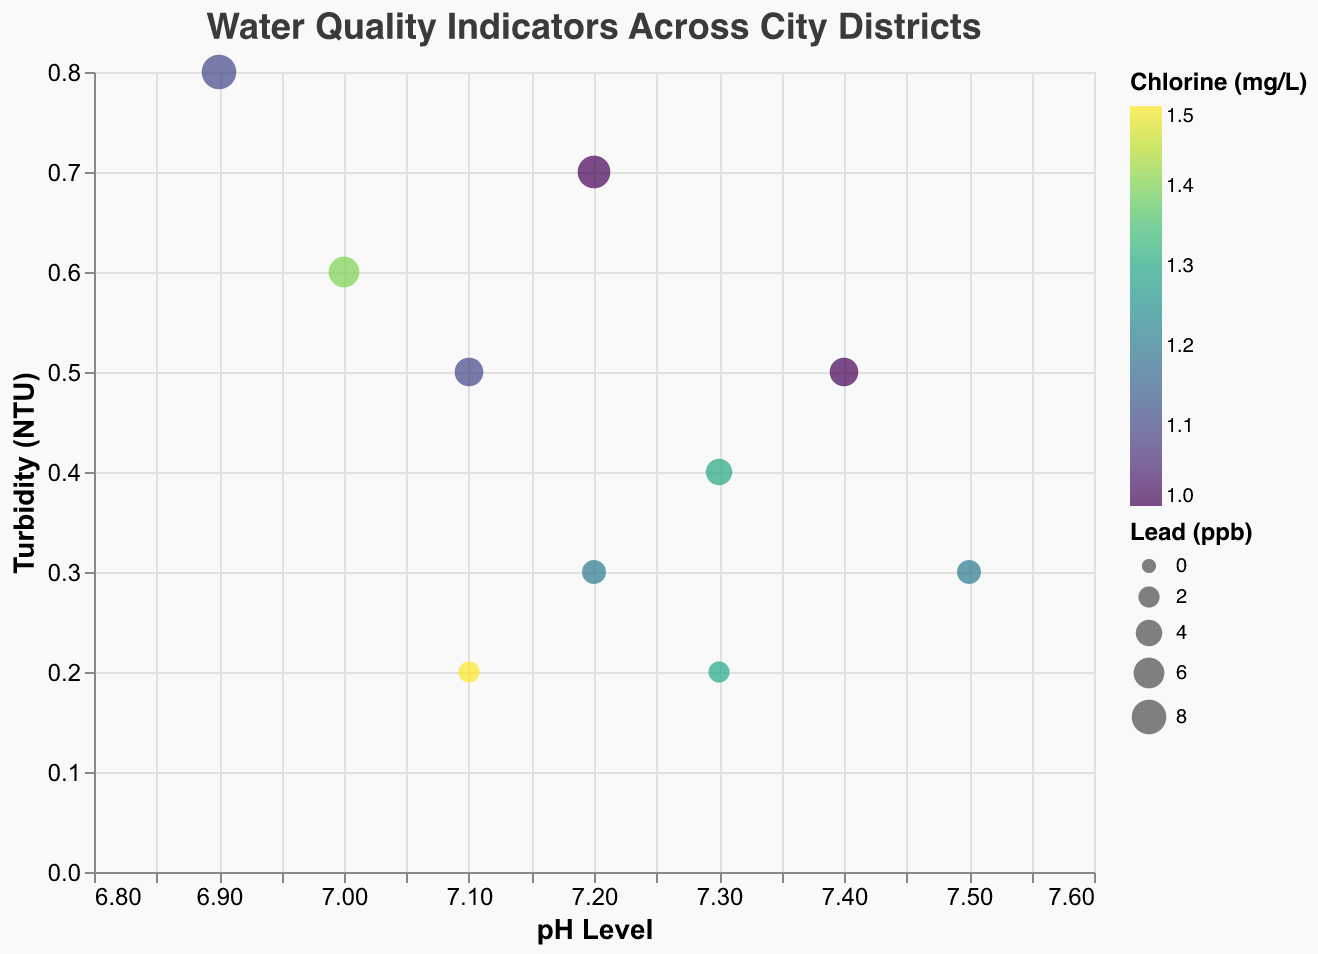How many districts are displayed in the figure? To answer this question, you simply need to count the number of distinct points representing districts on the plot. There are 10 distinct points, each corresponding to one district.
Answer: 10 Which district has the lowest pH value? To determine the district with the lowest pH value, look for the data point that is furthest to the left on the x-axis. The "Industrial Park" district has the lowest pH value of 6.9.
Answer: Industrial Park What is the range of Chlorine levels in the districts? Examine the Chlorine scale represented by the color of the points on the plot. The minimum Chlorine value is 1.0 mg/L and the maximum is 1.5 mg/L. The range is calculated as 1.5 - 1.0 = 0.5 mg/L.
Answer: 0.5 mg/L Which district has the highest Lead concentration? Identify the data point with the largest circle size, as circle size is proportional to the Lead concentration. The largest circle belongs to the "Industrial Park" district with 8 ppb of Lead.
Answer: Industrial Park How do the pH and Turbidity levels compare between "Downtown" and "Green Valley"? Look at the positions of "Downtown" and "Green Valley" on the plot. "Downtown" has a pH of 7.2 and Turbidity of 0.3 NTU, while "Green Valley" has a pH of 7.3 and Turbidity of 0.2 NTU. "Green Valley" has a slightly higher pH and lower Turbidity than "Downtown".
Answer: pH: Green Valley > Downtown, Turbidity: Green Valley < Downtown What is the average pH value of all districts? To find the average pH value, sum the pH values of all districts and divide by the number of districts: (7.2 + 7.4 + 7.1 + 6.9 + 7.3 + 7.0 + 7.5 + 7.2 + 7.3 + 7.1)/10 = 7.1.
Answer: 7.1 Which districts have no detectable E. coli levels? Identify data points where the E. coli value is 0. Districts with no detectable E. coli include "Downtown", "Hillside", "Suburbia", "Lakeview", and "Green Valley".
Answer: Downtown, Hillside, Suburbia, Lakeview, Green Valley How does "University Area" compare to "Old Town" in terms of Turbidity and Lead levels? Check the positions and sizes of the "University Area" and "Old Town" data points. "University Area" has a Turbidity of 0.6 NTU and Lead of 6 ppb, while "Old Town" has a Turbidity of 0.7 NTU and Lead of 7 ppb. "Old Town" has slightly higher Turbidity and Lead levels than "University Area".
Answer: University Area < Old Town in both Turbidity and Lead levels Is there a correlation visible between pH and Turbidity levels across the districts? Observe the distribution of the points across the x-axis (pH) and y-axis (Turbidity). There is no clear linear correlation observable between pH and Turbidity levels across the districts; the points are fairly dispersed.
Answer: No clear correlation 